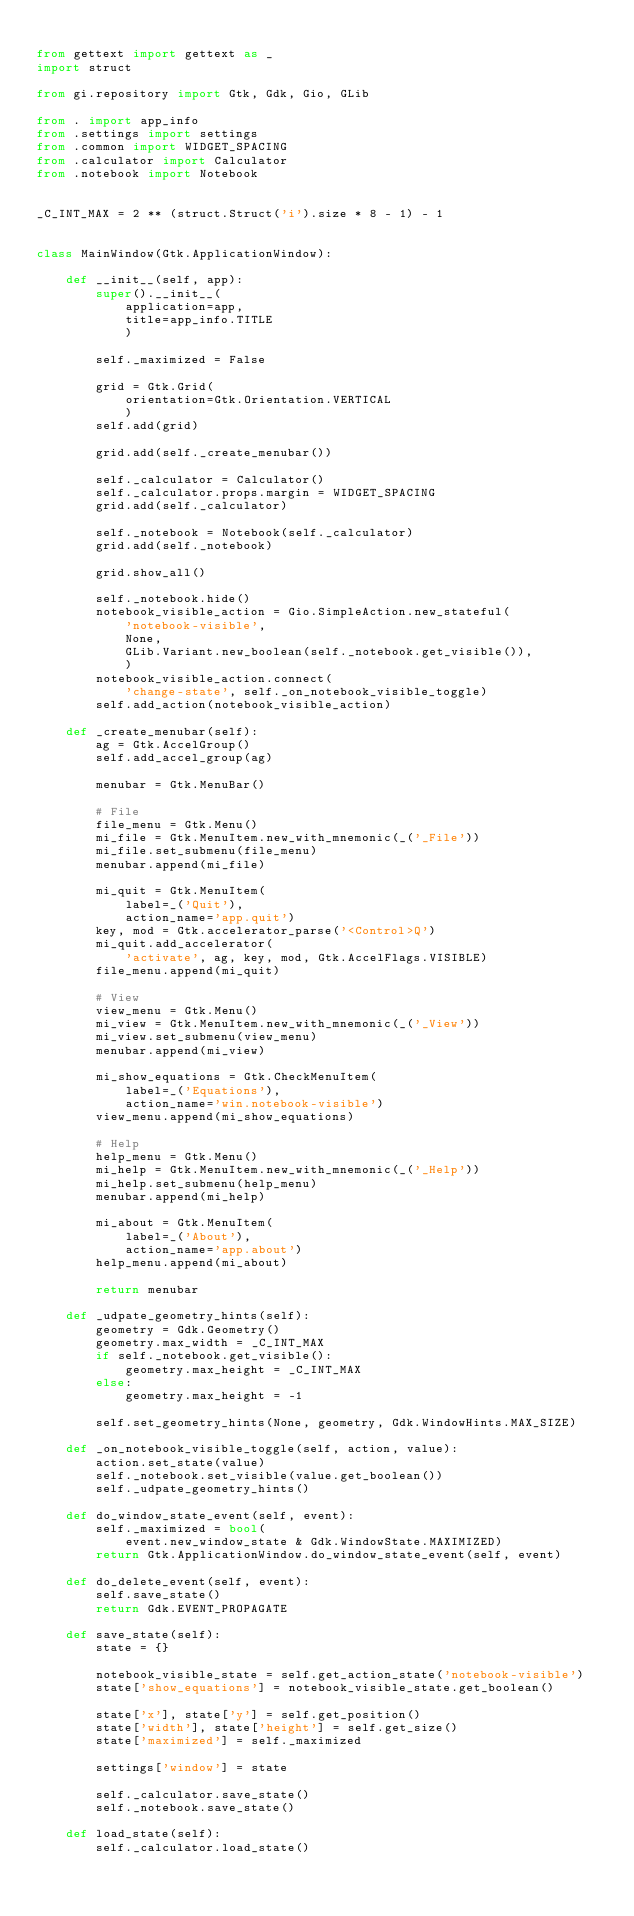Convert code to text. <code><loc_0><loc_0><loc_500><loc_500><_Python_>
from gettext import gettext as _
import struct

from gi.repository import Gtk, Gdk, Gio, GLib

from . import app_info
from .settings import settings
from .common import WIDGET_SPACING
from .calculator import Calculator
from .notebook import Notebook


_C_INT_MAX = 2 ** (struct.Struct('i').size * 8 - 1) - 1


class MainWindow(Gtk.ApplicationWindow):

    def __init__(self, app):
        super().__init__(
            application=app,
            title=app_info.TITLE
            )

        self._maximized = False

        grid = Gtk.Grid(
            orientation=Gtk.Orientation.VERTICAL
            )
        self.add(grid)

        grid.add(self._create_menubar())

        self._calculator = Calculator()
        self._calculator.props.margin = WIDGET_SPACING
        grid.add(self._calculator)

        self._notebook = Notebook(self._calculator)
        grid.add(self._notebook)

        grid.show_all()

        self._notebook.hide()
        notebook_visible_action = Gio.SimpleAction.new_stateful(
            'notebook-visible',
            None,
            GLib.Variant.new_boolean(self._notebook.get_visible()),
            )
        notebook_visible_action.connect(
            'change-state', self._on_notebook_visible_toggle)
        self.add_action(notebook_visible_action)

    def _create_menubar(self):
        ag = Gtk.AccelGroup()
        self.add_accel_group(ag)

        menubar = Gtk.MenuBar()

        # File
        file_menu = Gtk.Menu()
        mi_file = Gtk.MenuItem.new_with_mnemonic(_('_File'))
        mi_file.set_submenu(file_menu)
        menubar.append(mi_file)

        mi_quit = Gtk.MenuItem(
            label=_('Quit'),
            action_name='app.quit')
        key, mod = Gtk.accelerator_parse('<Control>Q')
        mi_quit.add_accelerator(
            'activate', ag, key, mod, Gtk.AccelFlags.VISIBLE)
        file_menu.append(mi_quit)

        # View
        view_menu = Gtk.Menu()
        mi_view = Gtk.MenuItem.new_with_mnemonic(_('_View'))
        mi_view.set_submenu(view_menu)
        menubar.append(mi_view)

        mi_show_equations = Gtk.CheckMenuItem(
            label=_('Equations'),
            action_name='win.notebook-visible')
        view_menu.append(mi_show_equations)

        # Help
        help_menu = Gtk.Menu()
        mi_help = Gtk.MenuItem.new_with_mnemonic(_('_Help'))
        mi_help.set_submenu(help_menu)
        menubar.append(mi_help)

        mi_about = Gtk.MenuItem(
            label=_('About'),
            action_name='app.about')
        help_menu.append(mi_about)

        return menubar

    def _udpate_geometry_hints(self):
        geometry = Gdk.Geometry()
        geometry.max_width = _C_INT_MAX
        if self._notebook.get_visible():
            geometry.max_height = _C_INT_MAX
        else:
            geometry.max_height = -1

        self.set_geometry_hints(None, geometry, Gdk.WindowHints.MAX_SIZE)

    def _on_notebook_visible_toggle(self, action, value):
        action.set_state(value)
        self._notebook.set_visible(value.get_boolean())
        self._udpate_geometry_hints()

    def do_window_state_event(self, event):
        self._maximized = bool(
            event.new_window_state & Gdk.WindowState.MAXIMIZED)
        return Gtk.ApplicationWindow.do_window_state_event(self, event)

    def do_delete_event(self, event):
        self.save_state()
        return Gdk.EVENT_PROPAGATE

    def save_state(self):
        state = {}

        notebook_visible_state = self.get_action_state('notebook-visible')
        state['show_equations'] = notebook_visible_state.get_boolean()

        state['x'], state['y'] = self.get_position()
        state['width'], state['height'] = self.get_size()
        state['maximized'] = self._maximized

        settings['window'] = state

        self._calculator.save_state()
        self._notebook.save_state()

    def load_state(self):
        self._calculator.load_state()</code> 